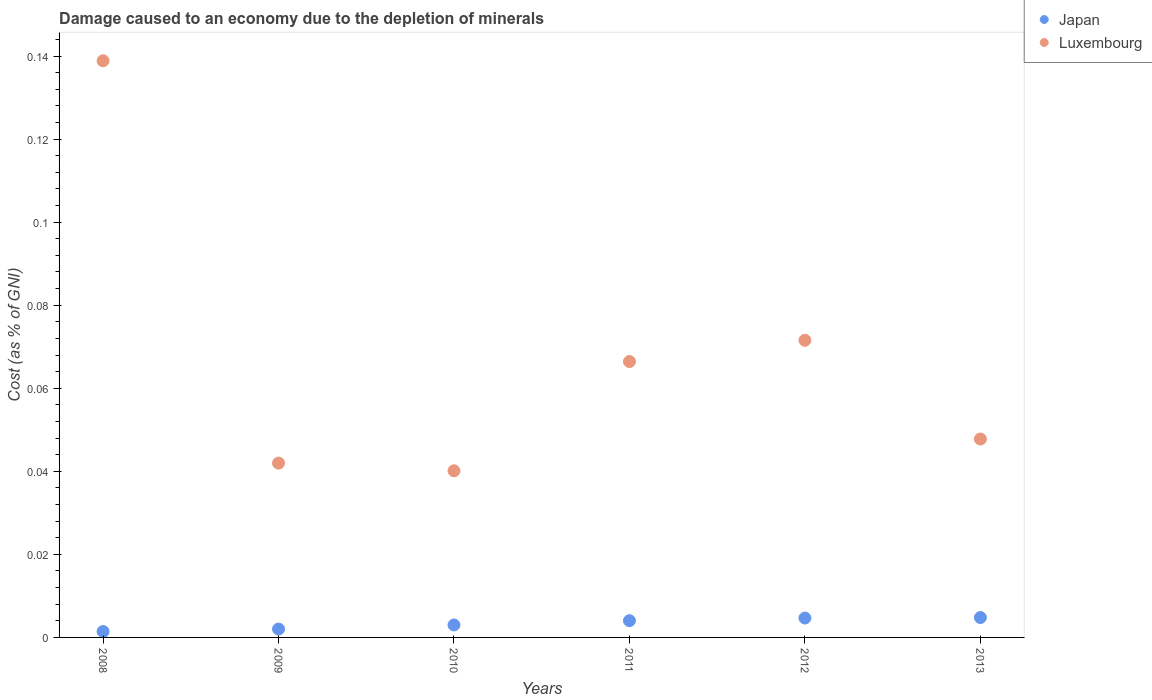How many different coloured dotlines are there?
Keep it short and to the point. 2. Is the number of dotlines equal to the number of legend labels?
Provide a succinct answer. Yes. What is the cost of damage caused due to the depletion of minerals in Luxembourg in 2013?
Make the answer very short. 0.05. Across all years, what is the maximum cost of damage caused due to the depletion of minerals in Japan?
Give a very brief answer. 0. Across all years, what is the minimum cost of damage caused due to the depletion of minerals in Luxembourg?
Provide a succinct answer. 0.04. In which year was the cost of damage caused due to the depletion of minerals in Japan minimum?
Provide a short and direct response. 2008. What is the total cost of damage caused due to the depletion of minerals in Japan in the graph?
Provide a succinct answer. 0.02. What is the difference between the cost of damage caused due to the depletion of minerals in Japan in 2009 and that in 2010?
Your answer should be compact. -0. What is the difference between the cost of damage caused due to the depletion of minerals in Japan in 2013 and the cost of damage caused due to the depletion of minerals in Luxembourg in 2012?
Your response must be concise. -0.07. What is the average cost of damage caused due to the depletion of minerals in Japan per year?
Offer a very short reply. 0. In the year 2011, what is the difference between the cost of damage caused due to the depletion of minerals in Luxembourg and cost of damage caused due to the depletion of minerals in Japan?
Offer a very short reply. 0.06. What is the ratio of the cost of damage caused due to the depletion of minerals in Luxembourg in 2009 to that in 2013?
Provide a short and direct response. 0.88. What is the difference between the highest and the second highest cost of damage caused due to the depletion of minerals in Luxembourg?
Your answer should be very brief. 0.07. What is the difference between the highest and the lowest cost of damage caused due to the depletion of minerals in Japan?
Make the answer very short. 0. Is the sum of the cost of damage caused due to the depletion of minerals in Luxembourg in 2008 and 2011 greater than the maximum cost of damage caused due to the depletion of minerals in Japan across all years?
Your answer should be very brief. Yes. Does the cost of damage caused due to the depletion of minerals in Luxembourg monotonically increase over the years?
Ensure brevity in your answer.  No. How many dotlines are there?
Offer a very short reply. 2. How many years are there in the graph?
Offer a very short reply. 6. What is the difference between two consecutive major ticks on the Y-axis?
Keep it short and to the point. 0.02. Are the values on the major ticks of Y-axis written in scientific E-notation?
Provide a short and direct response. No. Does the graph contain grids?
Your response must be concise. No. Where does the legend appear in the graph?
Your answer should be compact. Top right. How many legend labels are there?
Offer a terse response. 2. What is the title of the graph?
Your answer should be compact. Damage caused to an economy due to the depletion of minerals. What is the label or title of the Y-axis?
Your response must be concise. Cost (as % of GNI). What is the Cost (as % of GNI) of Japan in 2008?
Provide a succinct answer. 0. What is the Cost (as % of GNI) in Luxembourg in 2008?
Keep it short and to the point. 0.14. What is the Cost (as % of GNI) in Japan in 2009?
Give a very brief answer. 0. What is the Cost (as % of GNI) in Luxembourg in 2009?
Give a very brief answer. 0.04. What is the Cost (as % of GNI) in Japan in 2010?
Keep it short and to the point. 0. What is the Cost (as % of GNI) of Luxembourg in 2010?
Provide a succinct answer. 0.04. What is the Cost (as % of GNI) in Japan in 2011?
Your answer should be very brief. 0. What is the Cost (as % of GNI) in Luxembourg in 2011?
Make the answer very short. 0.07. What is the Cost (as % of GNI) in Japan in 2012?
Give a very brief answer. 0. What is the Cost (as % of GNI) in Luxembourg in 2012?
Provide a succinct answer. 0.07. What is the Cost (as % of GNI) of Japan in 2013?
Provide a short and direct response. 0. What is the Cost (as % of GNI) in Luxembourg in 2013?
Give a very brief answer. 0.05. Across all years, what is the maximum Cost (as % of GNI) in Japan?
Your response must be concise. 0. Across all years, what is the maximum Cost (as % of GNI) of Luxembourg?
Your answer should be compact. 0.14. Across all years, what is the minimum Cost (as % of GNI) in Japan?
Keep it short and to the point. 0. Across all years, what is the minimum Cost (as % of GNI) of Luxembourg?
Offer a very short reply. 0.04. What is the total Cost (as % of GNI) in Japan in the graph?
Give a very brief answer. 0.02. What is the total Cost (as % of GNI) in Luxembourg in the graph?
Offer a terse response. 0.41. What is the difference between the Cost (as % of GNI) in Japan in 2008 and that in 2009?
Provide a succinct answer. -0. What is the difference between the Cost (as % of GNI) of Luxembourg in 2008 and that in 2009?
Your response must be concise. 0.1. What is the difference between the Cost (as % of GNI) of Japan in 2008 and that in 2010?
Your answer should be compact. -0. What is the difference between the Cost (as % of GNI) in Luxembourg in 2008 and that in 2010?
Offer a very short reply. 0.1. What is the difference between the Cost (as % of GNI) in Japan in 2008 and that in 2011?
Make the answer very short. -0. What is the difference between the Cost (as % of GNI) in Luxembourg in 2008 and that in 2011?
Ensure brevity in your answer.  0.07. What is the difference between the Cost (as % of GNI) in Japan in 2008 and that in 2012?
Your answer should be very brief. -0. What is the difference between the Cost (as % of GNI) of Luxembourg in 2008 and that in 2012?
Keep it short and to the point. 0.07. What is the difference between the Cost (as % of GNI) in Japan in 2008 and that in 2013?
Offer a very short reply. -0. What is the difference between the Cost (as % of GNI) in Luxembourg in 2008 and that in 2013?
Provide a succinct answer. 0.09. What is the difference between the Cost (as % of GNI) in Japan in 2009 and that in 2010?
Make the answer very short. -0. What is the difference between the Cost (as % of GNI) of Luxembourg in 2009 and that in 2010?
Give a very brief answer. 0. What is the difference between the Cost (as % of GNI) of Japan in 2009 and that in 2011?
Offer a terse response. -0. What is the difference between the Cost (as % of GNI) in Luxembourg in 2009 and that in 2011?
Your response must be concise. -0.02. What is the difference between the Cost (as % of GNI) in Japan in 2009 and that in 2012?
Offer a very short reply. -0. What is the difference between the Cost (as % of GNI) of Luxembourg in 2009 and that in 2012?
Provide a short and direct response. -0.03. What is the difference between the Cost (as % of GNI) of Japan in 2009 and that in 2013?
Offer a terse response. -0. What is the difference between the Cost (as % of GNI) of Luxembourg in 2009 and that in 2013?
Your answer should be compact. -0.01. What is the difference between the Cost (as % of GNI) in Japan in 2010 and that in 2011?
Provide a succinct answer. -0. What is the difference between the Cost (as % of GNI) in Luxembourg in 2010 and that in 2011?
Ensure brevity in your answer.  -0.03. What is the difference between the Cost (as % of GNI) of Japan in 2010 and that in 2012?
Your response must be concise. -0. What is the difference between the Cost (as % of GNI) of Luxembourg in 2010 and that in 2012?
Your answer should be compact. -0.03. What is the difference between the Cost (as % of GNI) in Japan in 2010 and that in 2013?
Your answer should be very brief. -0. What is the difference between the Cost (as % of GNI) in Luxembourg in 2010 and that in 2013?
Offer a terse response. -0.01. What is the difference between the Cost (as % of GNI) in Japan in 2011 and that in 2012?
Your response must be concise. -0. What is the difference between the Cost (as % of GNI) in Luxembourg in 2011 and that in 2012?
Provide a short and direct response. -0.01. What is the difference between the Cost (as % of GNI) in Japan in 2011 and that in 2013?
Your response must be concise. -0. What is the difference between the Cost (as % of GNI) in Luxembourg in 2011 and that in 2013?
Your answer should be compact. 0.02. What is the difference between the Cost (as % of GNI) in Japan in 2012 and that in 2013?
Provide a short and direct response. -0. What is the difference between the Cost (as % of GNI) of Luxembourg in 2012 and that in 2013?
Provide a succinct answer. 0.02. What is the difference between the Cost (as % of GNI) in Japan in 2008 and the Cost (as % of GNI) in Luxembourg in 2009?
Give a very brief answer. -0.04. What is the difference between the Cost (as % of GNI) of Japan in 2008 and the Cost (as % of GNI) of Luxembourg in 2010?
Keep it short and to the point. -0.04. What is the difference between the Cost (as % of GNI) in Japan in 2008 and the Cost (as % of GNI) in Luxembourg in 2011?
Give a very brief answer. -0.07. What is the difference between the Cost (as % of GNI) of Japan in 2008 and the Cost (as % of GNI) of Luxembourg in 2012?
Keep it short and to the point. -0.07. What is the difference between the Cost (as % of GNI) in Japan in 2008 and the Cost (as % of GNI) in Luxembourg in 2013?
Make the answer very short. -0.05. What is the difference between the Cost (as % of GNI) of Japan in 2009 and the Cost (as % of GNI) of Luxembourg in 2010?
Ensure brevity in your answer.  -0.04. What is the difference between the Cost (as % of GNI) in Japan in 2009 and the Cost (as % of GNI) in Luxembourg in 2011?
Your answer should be very brief. -0.06. What is the difference between the Cost (as % of GNI) in Japan in 2009 and the Cost (as % of GNI) in Luxembourg in 2012?
Keep it short and to the point. -0.07. What is the difference between the Cost (as % of GNI) in Japan in 2009 and the Cost (as % of GNI) in Luxembourg in 2013?
Give a very brief answer. -0.05. What is the difference between the Cost (as % of GNI) in Japan in 2010 and the Cost (as % of GNI) in Luxembourg in 2011?
Give a very brief answer. -0.06. What is the difference between the Cost (as % of GNI) in Japan in 2010 and the Cost (as % of GNI) in Luxembourg in 2012?
Your answer should be compact. -0.07. What is the difference between the Cost (as % of GNI) of Japan in 2010 and the Cost (as % of GNI) of Luxembourg in 2013?
Keep it short and to the point. -0.04. What is the difference between the Cost (as % of GNI) in Japan in 2011 and the Cost (as % of GNI) in Luxembourg in 2012?
Offer a very short reply. -0.07. What is the difference between the Cost (as % of GNI) of Japan in 2011 and the Cost (as % of GNI) of Luxembourg in 2013?
Your response must be concise. -0.04. What is the difference between the Cost (as % of GNI) in Japan in 2012 and the Cost (as % of GNI) in Luxembourg in 2013?
Your response must be concise. -0.04. What is the average Cost (as % of GNI) in Japan per year?
Provide a short and direct response. 0. What is the average Cost (as % of GNI) of Luxembourg per year?
Provide a succinct answer. 0.07. In the year 2008, what is the difference between the Cost (as % of GNI) of Japan and Cost (as % of GNI) of Luxembourg?
Provide a succinct answer. -0.14. In the year 2009, what is the difference between the Cost (as % of GNI) in Japan and Cost (as % of GNI) in Luxembourg?
Keep it short and to the point. -0.04. In the year 2010, what is the difference between the Cost (as % of GNI) in Japan and Cost (as % of GNI) in Luxembourg?
Make the answer very short. -0.04. In the year 2011, what is the difference between the Cost (as % of GNI) in Japan and Cost (as % of GNI) in Luxembourg?
Give a very brief answer. -0.06. In the year 2012, what is the difference between the Cost (as % of GNI) in Japan and Cost (as % of GNI) in Luxembourg?
Keep it short and to the point. -0.07. In the year 2013, what is the difference between the Cost (as % of GNI) in Japan and Cost (as % of GNI) in Luxembourg?
Offer a terse response. -0.04. What is the ratio of the Cost (as % of GNI) of Japan in 2008 to that in 2009?
Make the answer very short. 0.71. What is the ratio of the Cost (as % of GNI) in Luxembourg in 2008 to that in 2009?
Give a very brief answer. 3.31. What is the ratio of the Cost (as % of GNI) in Japan in 2008 to that in 2010?
Keep it short and to the point. 0.47. What is the ratio of the Cost (as % of GNI) of Luxembourg in 2008 to that in 2010?
Ensure brevity in your answer.  3.46. What is the ratio of the Cost (as % of GNI) in Japan in 2008 to that in 2011?
Offer a terse response. 0.35. What is the ratio of the Cost (as % of GNI) of Luxembourg in 2008 to that in 2011?
Your answer should be compact. 2.09. What is the ratio of the Cost (as % of GNI) of Japan in 2008 to that in 2012?
Your response must be concise. 0.3. What is the ratio of the Cost (as % of GNI) of Luxembourg in 2008 to that in 2012?
Give a very brief answer. 1.94. What is the ratio of the Cost (as % of GNI) in Japan in 2008 to that in 2013?
Provide a succinct answer. 0.3. What is the ratio of the Cost (as % of GNI) in Luxembourg in 2008 to that in 2013?
Your response must be concise. 2.91. What is the ratio of the Cost (as % of GNI) of Japan in 2009 to that in 2010?
Give a very brief answer. 0.67. What is the ratio of the Cost (as % of GNI) of Luxembourg in 2009 to that in 2010?
Give a very brief answer. 1.05. What is the ratio of the Cost (as % of GNI) of Japan in 2009 to that in 2011?
Offer a terse response. 0.5. What is the ratio of the Cost (as % of GNI) of Luxembourg in 2009 to that in 2011?
Provide a succinct answer. 0.63. What is the ratio of the Cost (as % of GNI) of Japan in 2009 to that in 2012?
Keep it short and to the point. 0.43. What is the ratio of the Cost (as % of GNI) of Luxembourg in 2009 to that in 2012?
Your response must be concise. 0.59. What is the ratio of the Cost (as % of GNI) of Japan in 2009 to that in 2013?
Keep it short and to the point. 0.42. What is the ratio of the Cost (as % of GNI) in Luxembourg in 2009 to that in 2013?
Your answer should be compact. 0.88. What is the ratio of the Cost (as % of GNI) of Japan in 2010 to that in 2011?
Your answer should be very brief. 0.75. What is the ratio of the Cost (as % of GNI) of Luxembourg in 2010 to that in 2011?
Give a very brief answer. 0.6. What is the ratio of the Cost (as % of GNI) of Japan in 2010 to that in 2012?
Your answer should be compact. 0.64. What is the ratio of the Cost (as % of GNI) of Luxembourg in 2010 to that in 2012?
Ensure brevity in your answer.  0.56. What is the ratio of the Cost (as % of GNI) of Japan in 2010 to that in 2013?
Offer a terse response. 0.63. What is the ratio of the Cost (as % of GNI) in Luxembourg in 2010 to that in 2013?
Provide a succinct answer. 0.84. What is the ratio of the Cost (as % of GNI) in Japan in 2011 to that in 2012?
Provide a succinct answer. 0.86. What is the ratio of the Cost (as % of GNI) in Luxembourg in 2011 to that in 2012?
Make the answer very short. 0.93. What is the ratio of the Cost (as % of GNI) of Japan in 2011 to that in 2013?
Provide a succinct answer. 0.84. What is the ratio of the Cost (as % of GNI) in Luxembourg in 2011 to that in 2013?
Provide a succinct answer. 1.39. What is the ratio of the Cost (as % of GNI) of Japan in 2012 to that in 2013?
Provide a short and direct response. 0.98. What is the ratio of the Cost (as % of GNI) in Luxembourg in 2012 to that in 2013?
Keep it short and to the point. 1.5. What is the difference between the highest and the second highest Cost (as % of GNI) in Luxembourg?
Keep it short and to the point. 0.07. What is the difference between the highest and the lowest Cost (as % of GNI) in Japan?
Your answer should be very brief. 0. What is the difference between the highest and the lowest Cost (as % of GNI) of Luxembourg?
Make the answer very short. 0.1. 